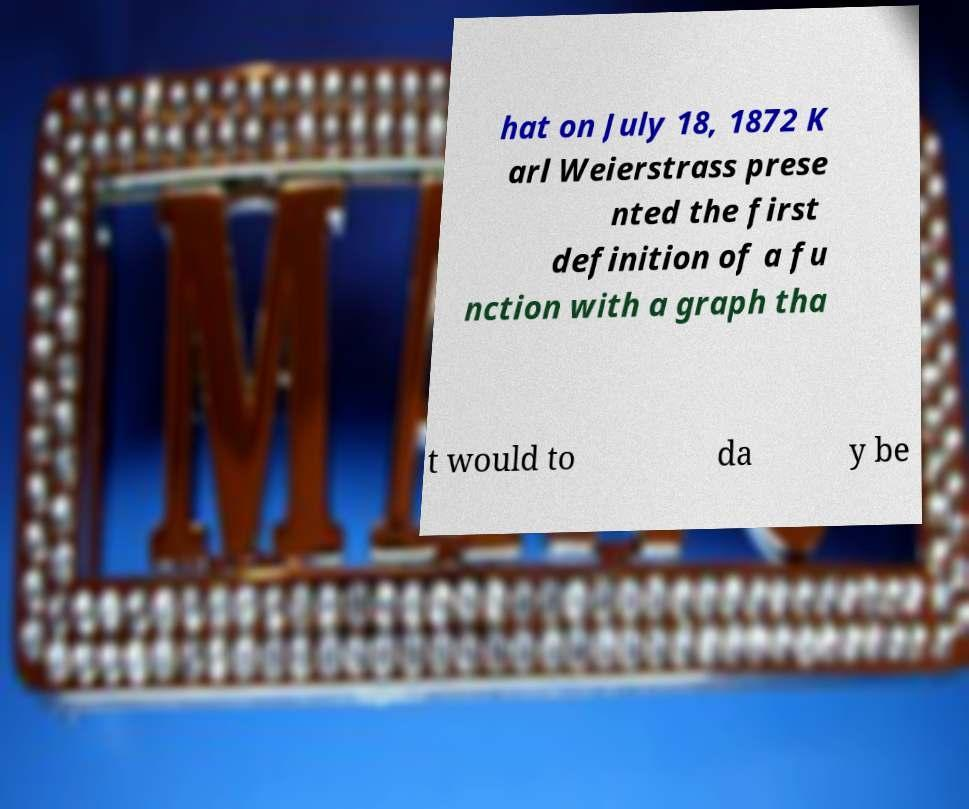Can you read and provide the text displayed in the image?This photo seems to have some interesting text. Can you extract and type it out for me? hat on July 18, 1872 K arl Weierstrass prese nted the first definition of a fu nction with a graph tha t would to da y be 